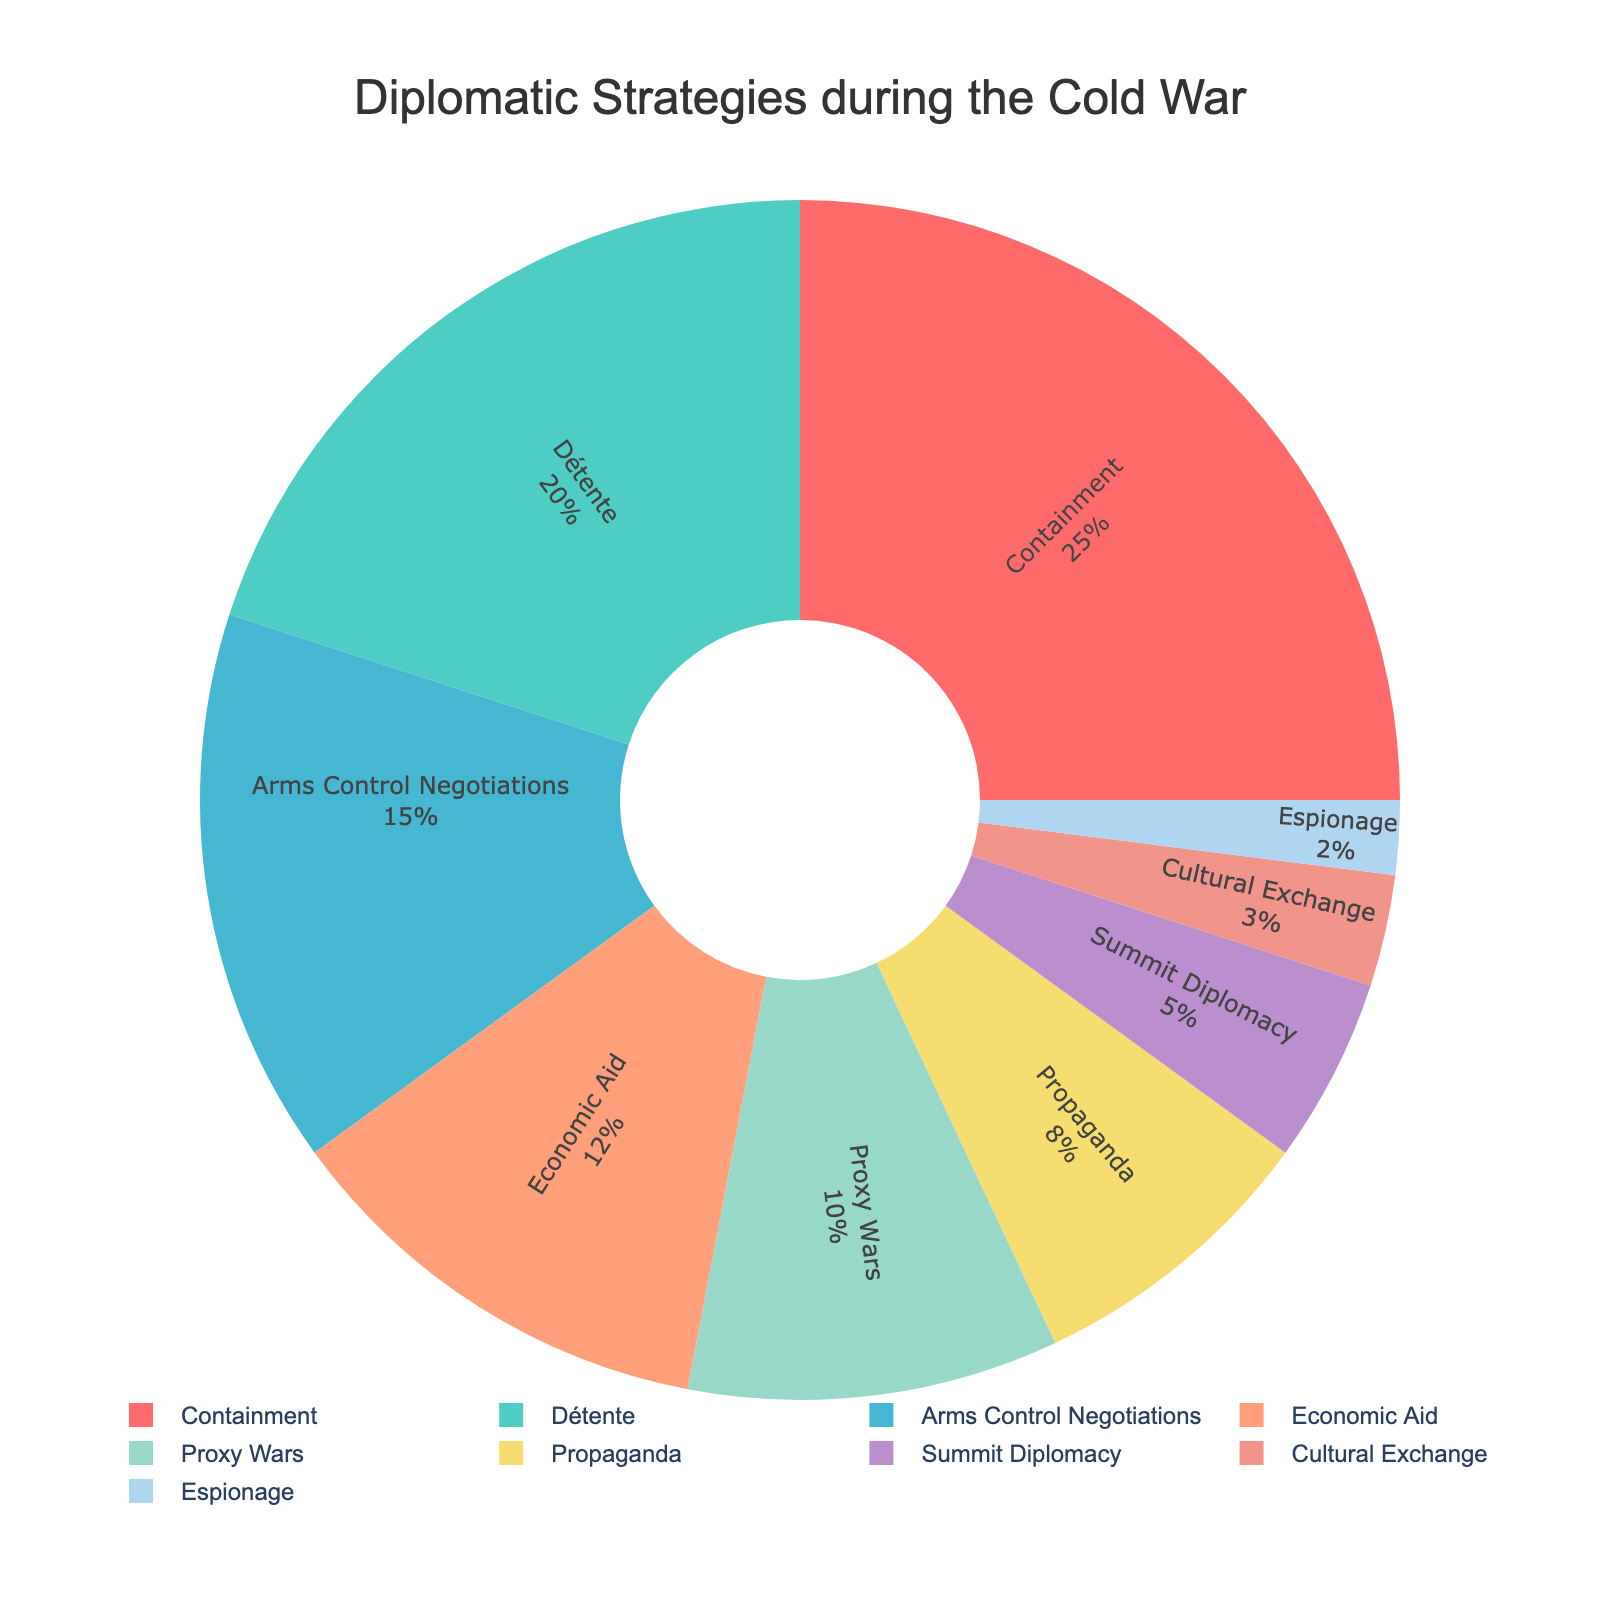Which diplomatic strategy was used the most? The figure shows that "Containment" occupies the largest portion of the pie chart, indicating it was used the most.
Answer: Containment Which two strategies together make up 35% of the total? According to the pie chart, "Containment" makes up 25% and "Détente" makes up 20%. Their combined percentage is 25% + 20% = 45%, but the question asks for 35%. So, it must be "Arms Control Negotiations" 15% and "Economic Aid" 12%. 15% + 12% = 27%. The correct combination is "Containment" (25%) + "Espionage" (2%) + "Cultural Exchange" (3%) = 30%. The combination for 35% is "Détente" (20%) and "Arms Control Negotiations" (15%) = 35%.
Answer: Détente and Arms Control Negotiations Which strategy is represented by the smallest section of the pie? The smallest section of the pie chart is the one with the smallest percentage, which is "Espionage" at 2%.
Answer: Espionage How much more percentage was "Containment" used compared to "Proxy Wars"? The percentage breakdown shows "Containment" at 25% and "Proxy Wars" at 10%. The difference is 25% - 10% = 15%.
Answer: 15% What percentage of the strategies involved negotiations, such as Détente and Arms Control Negotiations? The figure indicates "Détente" at 20% and "Arms Control Negotiations" at 15%. Adding them gives 20% + 15% = 35%.
Answer: 35% Ignoring the top three strategies (Containment, Détente, and Arms Control Negotiations), what is the average percentage of the remaining strategies? Removing the top three strategies leaves us with percentages 12%, 10%, 8%, 5%, 3%, 2%. Adding these and dividing by the number of categories (6) gives us (12 + 10 + 8 + 5 + 3 + 2) / 6 = 40 / 6 ≈ 6.67%.
Answer: 6.67% Are there more strategies representing a percentage of 10% or less, or more representing more than 10%? The strategies with 10% or less are: Proxy Wars (10%), Propaganda (8%), Summit Diplomacy (5%), Cultural Exchange (3%), and Espionage (2%) - totaling 5 strategies. More than 10% are Containment (25%), Détente (20%), Arms Control Negotiations (15%), and Economic Aid (12%) - totaling 4 strategies.
Answer: 10% or less Which color represents the strategy that makes up 8% of the total? The pie charts use different colors for each strategy. The 8% segment corresponds to "Propaganda." Visually checking the color for the 8% segment identifies the color used in the chart for "Propaganda."
Answer: The color representing 8% is the same specified in the equal segment of the pie-chart of the strategy named Propaganda What strategies combined make up half (50%) of the total percentages? Adding the percentages in the descending order until reaching 50%: "Containment" (25%) + "Détente" (20%) = 45%. Adding the next highest, "Arms Control Negotiations" (15%), results in a total of 60%, which exceeds 50%. So the answer must be the first segment summing directly to cover 50%. This necessitates the first three strategies combined "Containment" (25%) + "Détente" (20%) + "Espionage" (2%) + "Cultural Exchange" (3%) => (45%).
Answer: Containment and Détente 